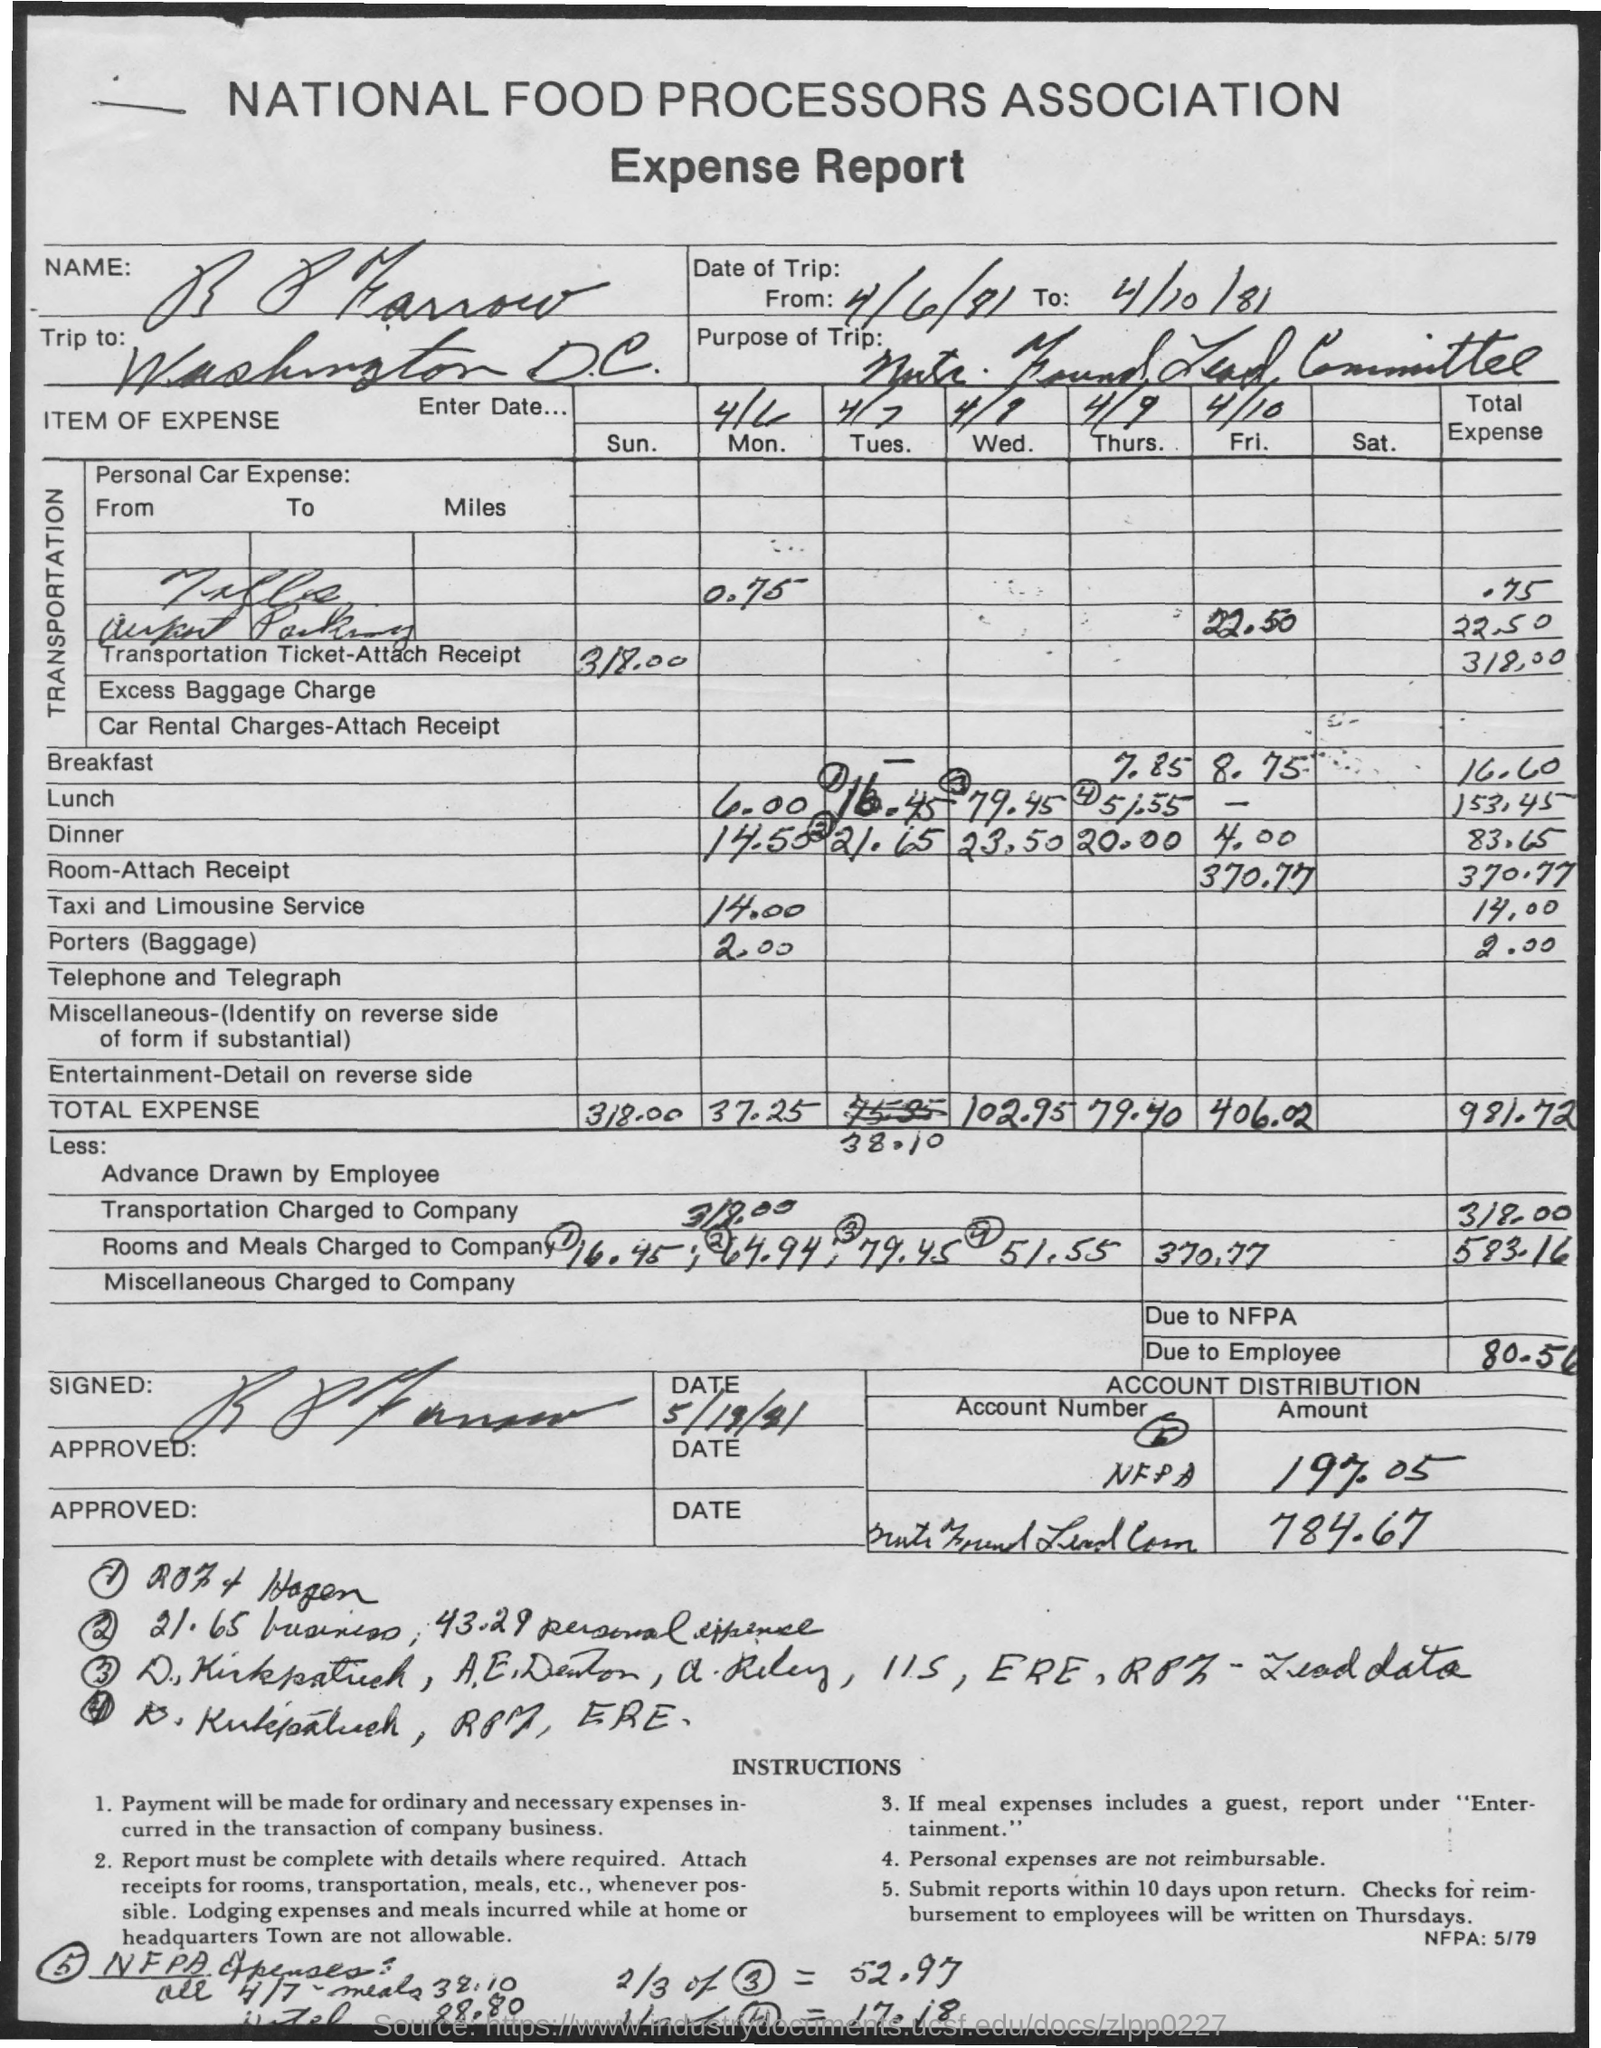What was the most significant expense category for the employee during this trip? The most significant expense category for the employee on this trip was 'Room-Attach Receipt', which amounted to $370.77, as detailed in the lodging section of the expense report. 